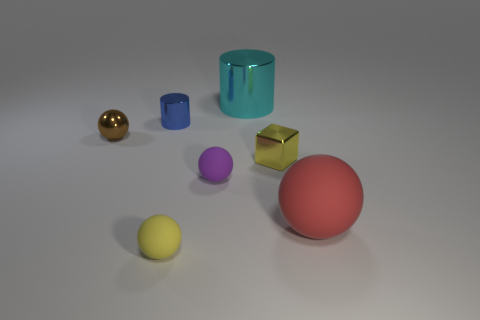Is there a sphere that has the same color as the small metallic block?
Provide a short and direct response. Yes. What number of blue objects are tiny matte blocks or tiny metal objects?
Give a very brief answer. 1. How many other things are there of the same size as the purple sphere?
Keep it short and to the point. 4. What number of small things are either spheres or purple matte things?
Your answer should be compact. 3. Do the cyan cylinder and the yellow object on the right side of the yellow rubber object have the same size?
Ensure brevity in your answer.  No. How many other objects are there of the same shape as the blue object?
Your answer should be very brief. 1. The yellow thing that is the same material as the cyan thing is what shape?
Keep it short and to the point. Cube. Are any red things visible?
Your answer should be compact. Yes. Is the number of small purple matte spheres behind the small brown ball less than the number of brown things that are left of the small blue metallic cylinder?
Offer a very short reply. Yes. There is a rubber thing that is right of the big cyan cylinder; what shape is it?
Provide a short and direct response. Sphere. 